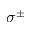Convert formula to latex. <formula><loc_0><loc_0><loc_500><loc_500>\sigma ^ { \pm }</formula> 